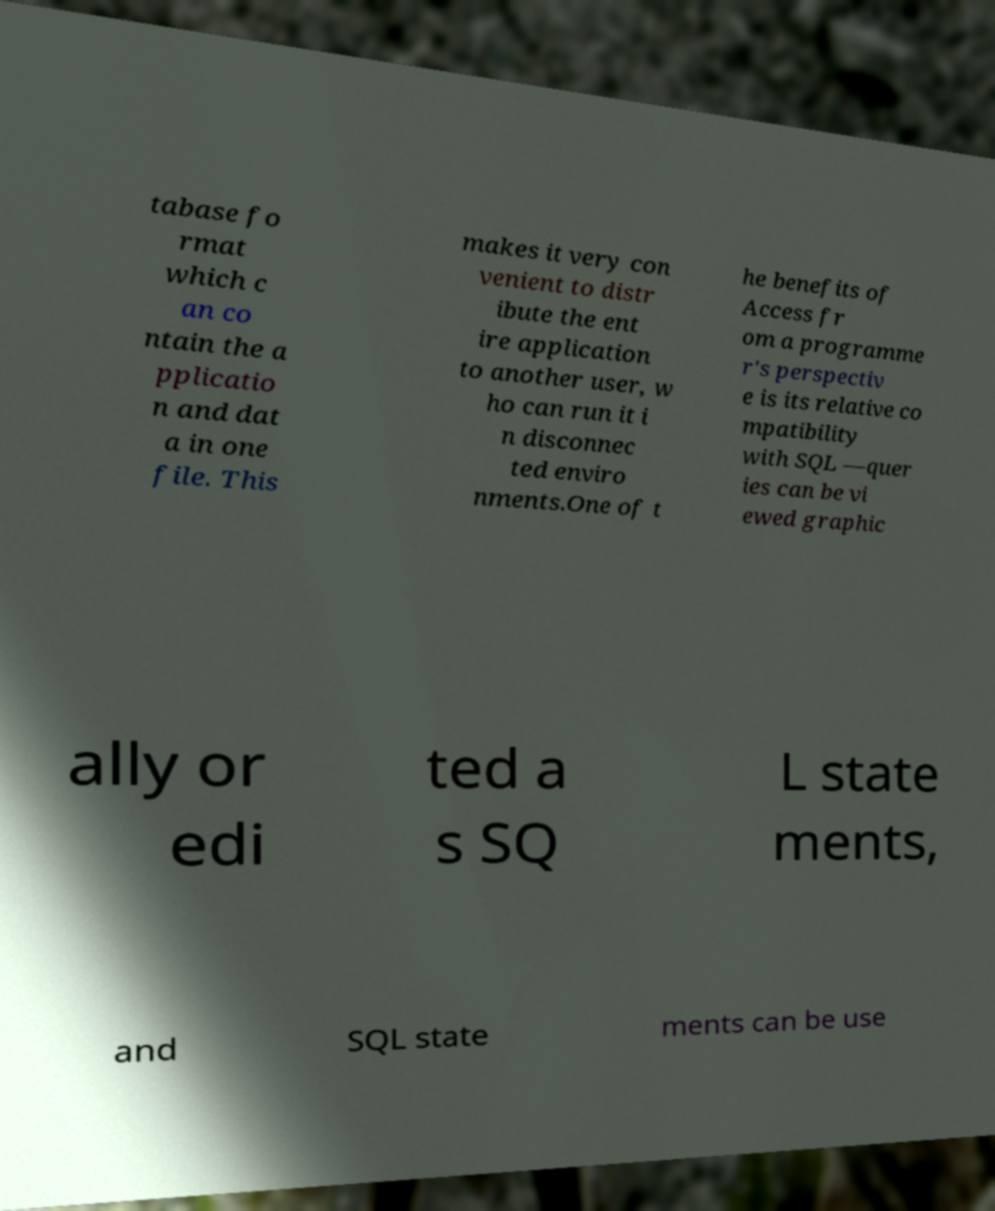Can you accurately transcribe the text from the provided image for me? tabase fo rmat which c an co ntain the a pplicatio n and dat a in one file. This makes it very con venient to distr ibute the ent ire application to another user, w ho can run it i n disconnec ted enviro nments.One of t he benefits of Access fr om a programme r's perspectiv e is its relative co mpatibility with SQL —quer ies can be vi ewed graphic ally or edi ted a s SQ L state ments, and SQL state ments can be use 